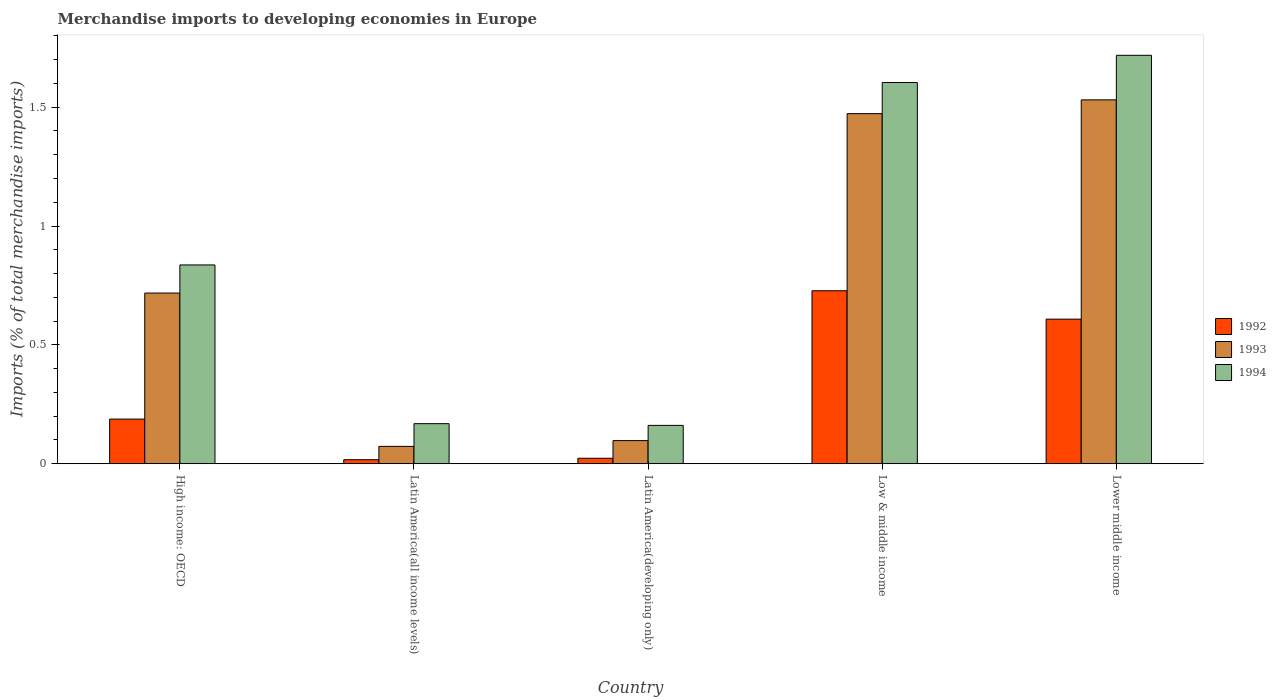How many different coloured bars are there?
Make the answer very short. 3. Are the number of bars per tick equal to the number of legend labels?
Give a very brief answer. Yes. How many bars are there on the 2nd tick from the left?
Offer a very short reply. 3. How many bars are there on the 3rd tick from the right?
Provide a succinct answer. 3. What is the label of the 2nd group of bars from the left?
Ensure brevity in your answer.  Latin America(all income levels). What is the percentage total merchandise imports in 1994 in Latin America(all income levels)?
Provide a short and direct response. 0.17. Across all countries, what is the maximum percentage total merchandise imports in 1993?
Make the answer very short. 1.53. Across all countries, what is the minimum percentage total merchandise imports in 1994?
Make the answer very short. 0.16. In which country was the percentage total merchandise imports in 1993 maximum?
Your answer should be very brief. Lower middle income. In which country was the percentage total merchandise imports in 1994 minimum?
Provide a succinct answer. Latin America(developing only). What is the total percentage total merchandise imports in 1994 in the graph?
Provide a short and direct response. 4.49. What is the difference between the percentage total merchandise imports in 1994 in Latin America(developing only) and that in Lower middle income?
Your answer should be very brief. -1.56. What is the difference between the percentage total merchandise imports in 1993 in Low & middle income and the percentage total merchandise imports in 1994 in High income: OECD?
Provide a succinct answer. 0.64. What is the average percentage total merchandise imports in 1992 per country?
Make the answer very short. 0.31. What is the difference between the percentage total merchandise imports of/in 1994 and percentage total merchandise imports of/in 1992 in Low & middle income?
Provide a short and direct response. 0.88. In how many countries, is the percentage total merchandise imports in 1994 greater than 0.9 %?
Provide a short and direct response. 2. What is the ratio of the percentage total merchandise imports in 1994 in High income: OECD to that in Low & middle income?
Offer a terse response. 0.52. Is the percentage total merchandise imports in 1994 in Latin America(all income levels) less than that in Low & middle income?
Make the answer very short. Yes. Is the difference between the percentage total merchandise imports in 1994 in Latin America(all income levels) and Latin America(developing only) greater than the difference between the percentage total merchandise imports in 1992 in Latin America(all income levels) and Latin America(developing only)?
Your answer should be very brief. Yes. What is the difference between the highest and the second highest percentage total merchandise imports in 1994?
Ensure brevity in your answer.  -0.88. What is the difference between the highest and the lowest percentage total merchandise imports in 1992?
Make the answer very short. 0.71. Is the sum of the percentage total merchandise imports in 1993 in Latin America(developing only) and Lower middle income greater than the maximum percentage total merchandise imports in 1992 across all countries?
Make the answer very short. Yes. Is it the case that in every country, the sum of the percentage total merchandise imports in 1994 and percentage total merchandise imports in 1993 is greater than the percentage total merchandise imports in 1992?
Provide a short and direct response. Yes. How many bars are there?
Give a very brief answer. 15. Are all the bars in the graph horizontal?
Keep it short and to the point. No. How many countries are there in the graph?
Offer a terse response. 5. Does the graph contain any zero values?
Provide a short and direct response. No. What is the title of the graph?
Provide a short and direct response. Merchandise imports to developing economies in Europe. Does "2014" appear as one of the legend labels in the graph?
Ensure brevity in your answer.  No. What is the label or title of the Y-axis?
Your answer should be compact. Imports (% of total merchandise imports). What is the Imports (% of total merchandise imports) in 1992 in High income: OECD?
Give a very brief answer. 0.19. What is the Imports (% of total merchandise imports) of 1993 in High income: OECD?
Offer a terse response. 0.72. What is the Imports (% of total merchandise imports) in 1994 in High income: OECD?
Your answer should be very brief. 0.84. What is the Imports (% of total merchandise imports) in 1992 in Latin America(all income levels)?
Make the answer very short. 0.02. What is the Imports (% of total merchandise imports) of 1993 in Latin America(all income levels)?
Offer a very short reply. 0.07. What is the Imports (% of total merchandise imports) in 1994 in Latin America(all income levels)?
Provide a short and direct response. 0.17. What is the Imports (% of total merchandise imports) of 1992 in Latin America(developing only)?
Give a very brief answer. 0.02. What is the Imports (% of total merchandise imports) of 1993 in Latin America(developing only)?
Provide a short and direct response. 0.1. What is the Imports (% of total merchandise imports) in 1994 in Latin America(developing only)?
Provide a short and direct response. 0.16. What is the Imports (% of total merchandise imports) in 1992 in Low & middle income?
Give a very brief answer. 0.73. What is the Imports (% of total merchandise imports) of 1993 in Low & middle income?
Provide a succinct answer. 1.47. What is the Imports (% of total merchandise imports) of 1994 in Low & middle income?
Provide a short and direct response. 1.6. What is the Imports (% of total merchandise imports) of 1992 in Lower middle income?
Provide a short and direct response. 0.61. What is the Imports (% of total merchandise imports) of 1993 in Lower middle income?
Offer a very short reply. 1.53. What is the Imports (% of total merchandise imports) in 1994 in Lower middle income?
Provide a short and direct response. 1.72. Across all countries, what is the maximum Imports (% of total merchandise imports) in 1992?
Offer a terse response. 0.73. Across all countries, what is the maximum Imports (% of total merchandise imports) in 1993?
Ensure brevity in your answer.  1.53. Across all countries, what is the maximum Imports (% of total merchandise imports) of 1994?
Your answer should be very brief. 1.72. Across all countries, what is the minimum Imports (% of total merchandise imports) of 1992?
Provide a short and direct response. 0.02. Across all countries, what is the minimum Imports (% of total merchandise imports) in 1993?
Give a very brief answer. 0.07. Across all countries, what is the minimum Imports (% of total merchandise imports) of 1994?
Your answer should be compact. 0.16. What is the total Imports (% of total merchandise imports) of 1992 in the graph?
Keep it short and to the point. 1.56. What is the total Imports (% of total merchandise imports) of 1993 in the graph?
Offer a very short reply. 3.89. What is the total Imports (% of total merchandise imports) of 1994 in the graph?
Keep it short and to the point. 4.49. What is the difference between the Imports (% of total merchandise imports) in 1992 in High income: OECD and that in Latin America(all income levels)?
Keep it short and to the point. 0.17. What is the difference between the Imports (% of total merchandise imports) of 1993 in High income: OECD and that in Latin America(all income levels)?
Your response must be concise. 0.65. What is the difference between the Imports (% of total merchandise imports) of 1994 in High income: OECD and that in Latin America(all income levels)?
Ensure brevity in your answer.  0.67. What is the difference between the Imports (% of total merchandise imports) in 1992 in High income: OECD and that in Latin America(developing only)?
Offer a very short reply. 0.16. What is the difference between the Imports (% of total merchandise imports) of 1993 in High income: OECD and that in Latin America(developing only)?
Your response must be concise. 0.62. What is the difference between the Imports (% of total merchandise imports) of 1994 in High income: OECD and that in Latin America(developing only)?
Provide a succinct answer. 0.67. What is the difference between the Imports (% of total merchandise imports) of 1992 in High income: OECD and that in Low & middle income?
Offer a very short reply. -0.54. What is the difference between the Imports (% of total merchandise imports) in 1993 in High income: OECD and that in Low & middle income?
Your response must be concise. -0.75. What is the difference between the Imports (% of total merchandise imports) of 1994 in High income: OECD and that in Low & middle income?
Provide a succinct answer. -0.77. What is the difference between the Imports (% of total merchandise imports) of 1992 in High income: OECD and that in Lower middle income?
Ensure brevity in your answer.  -0.42. What is the difference between the Imports (% of total merchandise imports) of 1993 in High income: OECD and that in Lower middle income?
Give a very brief answer. -0.81. What is the difference between the Imports (% of total merchandise imports) in 1994 in High income: OECD and that in Lower middle income?
Your answer should be very brief. -0.88. What is the difference between the Imports (% of total merchandise imports) of 1992 in Latin America(all income levels) and that in Latin America(developing only)?
Offer a terse response. -0.01. What is the difference between the Imports (% of total merchandise imports) of 1993 in Latin America(all income levels) and that in Latin America(developing only)?
Offer a very short reply. -0.02. What is the difference between the Imports (% of total merchandise imports) of 1994 in Latin America(all income levels) and that in Latin America(developing only)?
Make the answer very short. 0.01. What is the difference between the Imports (% of total merchandise imports) in 1992 in Latin America(all income levels) and that in Low & middle income?
Your answer should be compact. -0.71. What is the difference between the Imports (% of total merchandise imports) in 1993 in Latin America(all income levels) and that in Low & middle income?
Keep it short and to the point. -1.4. What is the difference between the Imports (% of total merchandise imports) in 1994 in Latin America(all income levels) and that in Low & middle income?
Ensure brevity in your answer.  -1.44. What is the difference between the Imports (% of total merchandise imports) in 1992 in Latin America(all income levels) and that in Lower middle income?
Your answer should be very brief. -0.59. What is the difference between the Imports (% of total merchandise imports) of 1993 in Latin America(all income levels) and that in Lower middle income?
Your answer should be very brief. -1.46. What is the difference between the Imports (% of total merchandise imports) in 1994 in Latin America(all income levels) and that in Lower middle income?
Your answer should be very brief. -1.55. What is the difference between the Imports (% of total merchandise imports) of 1992 in Latin America(developing only) and that in Low & middle income?
Offer a terse response. -0.7. What is the difference between the Imports (% of total merchandise imports) of 1993 in Latin America(developing only) and that in Low & middle income?
Provide a succinct answer. -1.38. What is the difference between the Imports (% of total merchandise imports) in 1994 in Latin America(developing only) and that in Low & middle income?
Keep it short and to the point. -1.44. What is the difference between the Imports (% of total merchandise imports) in 1992 in Latin America(developing only) and that in Lower middle income?
Offer a terse response. -0.59. What is the difference between the Imports (% of total merchandise imports) of 1993 in Latin America(developing only) and that in Lower middle income?
Offer a very short reply. -1.43. What is the difference between the Imports (% of total merchandise imports) in 1994 in Latin America(developing only) and that in Lower middle income?
Ensure brevity in your answer.  -1.56. What is the difference between the Imports (% of total merchandise imports) of 1992 in Low & middle income and that in Lower middle income?
Offer a very short reply. 0.12. What is the difference between the Imports (% of total merchandise imports) in 1993 in Low & middle income and that in Lower middle income?
Provide a succinct answer. -0.06. What is the difference between the Imports (% of total merchandise imports) of 1994 in Low & middle income and that in Lower middle income?
Make the answer very short. -0.11. What is the difference between the Imports (% of total merchandise imports) of 1992 in High income: OECD and the Imports (% of total merchandise imports) of 1993 in Latin America(all income levels)?
Provide a short and direct response. 0.11. What is the difference between the Imports (% of total merchandise imports) in 1992 in High income: OECD and the Imports (% of total merchandise imports) in 1994 in Latin America(all income levels)?
Offer a terse response. 0.02. What is the difference between the Imports (% of total merchandise imports) of 1993 in High income: OECD and the Imports (% of total merchandise imports) of 1994 in Latin America(all income levels)?
Give a very brief answer. 0.55. What is the difference between the Imports (% of total merchandise imports) of 1992 in High income: OECD and the Imports (% of total merchandise imports) of 1993 in Latin America(developing only)?
Your response must be concise. 0.09. What is the difference between the Imports (% of total merchandise imports) of 1992 in High income: OECD and the Imports (% of total merchandise imports) of 1994 in Latin America(developing only)?
Make the answer very short. 0.03. What is the difference between the Imports (% of total merchandise imports) of 1993 in High income: OECD and the Imports (% of total merchandise imports) of 1994 in Latin America(developing only)?
Your answer should be very brief. 0.56. What is the difference between the Imports (% of total merchandise imports) in 1992 in High income: OECD and the Imports (% of total merchandise imports) in 1993 in Low & middle income?
Your response must be concise. -1.28. What is the difference between the Imports (% of total merchandise imports) of 1992 in High income: OECD and the Imports (% of total merchandise imports) of 1994 in Low & middle income?
Give a very brief answer. -1.42. What is the difference between the Imports (% of total merchandise imports) of 1993 in High income: OECD and the Imports (% of total merchandise imports) of 1994 in Low & middle income?
Make the answer very short. -0.89. What is the difference between the Imports (% of total merchandise imports) of 1992 in High income: OECD and the Imports (% of total merchandise imports) of 1993 in Lower middle income?
Provide a succinct answer. -1.34. What is the difference between the Imports (% of total merchandise imports) of 1992 in High income: OECD and the Imports (% of total merchandise imports) of 1994 in Lower middle income?
Offer a very short reply. -1.53. What is the difference between the Imports (% of total merchandise imports) in 1993 in High income: OECD and the Imports (% of total merchandise imports) in 1994 in Lower middle income?
Your response must be concise. -1. What is the difference between the Imports (% of total merchandise imports) in 1992 in Latin America(all income levels) and the Imports (% of total merchandise imports) in 1993 in Latin America(developing only)?
Ensure brevity in your answer.  -0.08. What is the difference between the Imports (% of total merchandise imports) in 1992 in Latin America(all income levels) and the Imports (% of total merchandise imports) in 1994 in Latin America(developing only)?
Provide a succinct answer. -0.14. What is the difference between the Imports (% of total merchandise imports) of 1993 in Latin America(all income levels) and the Imports (% of total merchandise imports) of 1994 in Latin America(developing only)?
Offer a terse response. -0.09. What is the difference between the Imports (% of total merchandise imports) of 1992 in Latin America(all income levels) and the Imports (% of total merchandise imports) of 1993 in Low & middle income?
Provide a succinct answer. -1.46. What is the difference between the Imports (% of total merchandise imports) of 1992 in Latin America(all income levels) and the Imports (% of total merchandise imports) of 1994 in Low & middle income?
Offer a very short reply. -1.59. What is the difference between the Imports (% of total merchandise imports) in 1993 in Latin America(all income levels) and the Imports (% of total merchandise imports) in 1994 in Low & middle income?
Keep it short and to the point. -1.53. What is the difference between the Imports (% of total merchandise imports) of 1992 in Latin America(all income levels) and the Imports (% of total merchandise imports) of 1993 in Lower middle income?
Provide a short and direct response. -1.51. What is the difference between the Imports (% of total merchandise imports) of 1992 in Latin America(all income levels) and the Imports (% of total merchandise imports) of 1994 in Lower middle income?
Your response must be concise. -1.7. What is the difference between the Imports (% of total merchandise imports) in 1993 in Latin America(all income levels) and the Imports (% of total merchandise imports) in 1994 in Lower middle income?
Your answer should be compact. -1.65. What is the difference between the Imports (% of total merchandise imports) in 1992 in Latin America(developing only) and the Imports (% of total merchandise imports) in 1993 in Low & middle income?
Provide a short and direct response. -1.45. What is the difference between the Imports (% of total merchandise imports) in 1992 in Latin America(developing only) and the Imports (% of total merchandise imports) in 1994 in Low & middle income?
Provide a short and direct response. -1.58. What is the difference between the Imports (% of total merchandise imports) in 1993 in Latin America(developing only) and the Imports (% of total merchandise imports) in 1994 in Low & middle income?
Make the answer very short. -1.51. What is the difference between the Imports (% of total merchandise imports) of 1992 in Latin America(developing only) and the Imports (% of total merchandise imports) of 1993 in Lower middle income?
Ensure brevity in your answer.  -1.51. What is the difference between the Imports (% of total merchandise imports) of 1992 in Latin America(developing only) and the Imports (% of total merchandise imports) of 1994 in Lower middle income?
Your answer should be compact. -1.7. What is the difference between the Imports (% of total merchandise imports) in 1993 in Latin America(developing only) and the Imports (% of total merchandise imports) in 1994 in Lower middle income?
Offer a terse response. -1.62. What is the difference between the Imports (% of total merchandise imports) in 1992 in Low & middle income and the Imports (% of total merchandise imports) in 1993 in Lower middle income?
Give a very brief answer. -0.8. What is the difference between the Imports (% of total merchandise imports) in 1992 in Low & middle income and the Imports (% of total merchandise imports) in 1994 in Lower middle income?
Provide a short and direct response. -0.99. What is the difference between the Imports (% of total merchandise imports) of 1993 in Low & middle income and the Imports (% of total merchandise imports) of 1994 in Lower middle income?
Ensure brevity in your answer.  -0.25. What is the average Imports (% of total merchandise imports) in 1992 per country?
Your response must be concise. 0.31. What is the average Imports (% of total merchandise imports) of 1993 per country?
Make the answer very short. 0.78. What is the average Imports (% of total merchandise imports) of 1994 per country?
Ensure brevity in your answer.  0.9. What is the difference between the Imports (% of total merchandise imports) of 1992 and Imports (% of total merchandise imports) of 1993 in High income: OECD?
Your answer should be compact. -0.53. What is the difference between the Imports (% of total merchandise imports) of 1992 and Imports (% of total merchandise imports) of 1994 in High income: OECD?
Ensure brevity in your answer.  -0.65. What is the difference between the Imports (% of total merchandise imports) in 1993 and Imports (% of total merchandise imports) in 1994 in High income: OECD?
Offer a very short reply. -0.12. What is the difference between the Imports (% of total merchandise imports) in 1992 and Imports (% of total merchandise imports) in 1993 in Latin America(all income levels)?
Give a very brief answer. -0.06. What is the difference between the Imports (% of total merchandise imports) of 1992 and Imports (% of total merchandise imports) of 1994 in Latin America(all income levels)?
Provide a succinct answer. -0.15. What is the difference between the Imports (% of total merchandise imports) of 1993 and Imports (% of total merchandise imports) of 1994 in Latin America(all income levels)?
Make the answer very short. -0.1. What is the difference between the Imports (% of total merchandise imports) of 1992 and Imports (% of total merchandise imports) of 1993 in Latin America(developing only)?
Your answer should be very brief. -0.07. What is the difference between the Imports (% of total merchandise imports) in 1992 and Imports (% of total merchandise imports) in 1994 in Latin America(developing only)?
Ensure brevity in your answer.  -0.14. What is the difference between the Imports (% of total merchandise imports) in 1993 and Imports (% of total merchandise imports) in 1994 in Latin America(developing only)?
Ensure brevity in your answer.  -0.06. What is the difference between the Imports (% of total merchandise imports) of 1992 and Imports (% of total merchandise imports) of 1993 in Low & middle income?
Offer a terse response. -0.74. What is the difference between the Imports (% of total merchandise imports) of 1992 and Imports (% of total merchandise imports) of 1994 in Low & middle income?
Your answer should be very brief. -0.88. What is the difference between the Imports (% of total merchandise imports) in 1993 and Imports (% of total merchandise imports) in 1994 in Low & middle income?
Give a very brief answer. -0.13. What is the difference between the Imports (% of total merchandise imports) of 1992 and Imports (% of total merchandise imports) of 1993 in Lower middle income?
Your response must be concise. -0.92. What is the difference between the Imports (% of total merchandise imports) of 1992 and Imports (% of total merchandise imports) of 1994 in Lower middle income?
Ensure brevity in your answer.  -1.11. What is the difference between the Imports (% of total merchandise imports) of 1993 and Imports (% of total merchandise imports) of 1994 in Lower middle income?
Keep it short and to the point. -0.19. What is the ratio of the Imports (% of total merchandise imports) in 1992 in High income: OECD to that in Latin America(all income levels)?
Give a very brief answer. 11.1. What is the ratio of the Imports (% of total merchandise imports) of 1993 in High income: OECD to that in Latin America(all income levels)?
Your answer should be very brief. 9.84. What is the ratio of the Imports (% of total merchandise imports) in 1994 in High income: OECD to that in Latin America(all income levels)?
Offer a very short reply. 4.96. What is the ratio of the Imports (% of total merchandise imports) of 1992 in High income: OECD to that in Latin America(developing only)?
Your answer should be very brief. 8.15. What is the ratio of the Imports (% of total merchandise imports) in 1993 in High income: OECD to that in Latin America(developing only)?
Your answer should be compact. 7.38. What is the ratio of the Imports (% of total merchandise imports) in 1994 in High income: OECD to that in Latin America(developing only)?
Your answer should be very brief. 5.18. What is the ratio of the Imports (% of total merchandise imports) in 1992 in High income: OECD to that in Low & middle income?
Make the answer very short. 0.26. What is the ratio of the Imports (% of total merchandise imports) of 1993 in High income: OECD to that in Low & middle income?
Your response must be concise. 0.49. What is the ratio of the Imports (% of total merchandise imports) in 1994 in High income: OECD to that in Low & middle income?
Provide a short and direct response. 0.52. What is the ratio of the Imports (% of total merchandise imports) of 1992 in High income: OECD to that in Lower middle income?
Offer a very short reply. 0.31. What is the ratio of the Imports (% of total merchandise imports) of 1993 in High income: OECD to that in Lower middle income?
Offer a terse response. 0.47. What is the ratio of the Imports (% of total merchandise imports) in 1994 in High income: OECD to that in Lower middle income?
Provide a short and direct response. 0.49. What is the ratio of the Imports (% of total merchandise imports) in 1992 in Latin America(all income levels) to that in Latin America(developing only)?
Give a very brief answer. 0.73. What is the ratio of the Imports (% of total merchandise imports) in 1993 in Latin America(all income levels) to that in Latin America(developing only)?
Give a very brief answer. 0.75. What is the ratio of the Imports (% of total merchandise imports) of 1994 in Latin America(all income levels) to that in Latin America(developing only)?
Your answer should be compact. 1.04. What is the ratio of the Imports (% of total merchandise imports) of 1992 in Latin America(all income levels) to that in Low & middle income?
Your answer should be very brief. 0.02. What is the ratio of the Imports (% of total merchandise imports) of 1993 in Latin America(all income levels) to that in Low & middle income?
Offer a very short reply. 0.05. What is the ratio of the Imports (% of total merchandise imports) of 1994 in Latin America(all income levels) to that in Low & middle income?
Provide a succinct answer. 0.11. What is the ratio of the Imports (% of total merchandise imports) of 1992 in Latin America(all income levels) to that in Lower middle income?
Your answer should be very brief. 0.03. What is the ratio of the Imports (% of total merchandise imports) of 1993 in Latin America(all income levels) to that in Lower middle income?
Keep it short and to the point. 0.05. What is the ratio of the Imports (% of total merchandise imports) of 1994 in Latin America(all income levels) to that in Lower middle income?
Offer a terse response. 0.1. What is the ratio of the Imports (% of total merchandise imports) in 1992 in Latin America(developing only) to that in Low & middle income?
Provide a short and direct response. 0.03. What is the ratio of the Imports (% of total merchandise imports) in 1993 in Latin America(developing only) to that in Low & middle income?
Offer a very short reply. 0.07. What is the ratio of the Imports (% of total merchandise imports) of 1994 in Latin America(developing only) to that in Low & middle income?
Provide a succinct answer. 0.1. What is the ratio of the Imports (% of total merchandise imports) of 1992 in Latin America(developing only) to that in Lower middle income?
Give a very brief answer. 0.04. What is the ratio of the Imports (% of total merchandise imports) of 1993 in Latin America(developing only) to that in Lower middle income?
Offer a very short reply. 0.06. What is the ratio of the Imports (% of total merchandise imports) of 1994 in Latin America(developing only) to that in Lower middle income?
Your answer should be compact. 0.09. What is the ratio of the Imports (% of total merchandise imports) in 1992 in Low & middle income to that in Lower middle income?
Ensure brevity in your answer.  1.2. What is the ratio of the Imports (% of total merchandise imports) in 1993 in Low & middle income to that in Lower middle income?
Your response must be concise. 0.96. What is the ratio of the Imports (% of total merchandise imports) in 1994 in Low & middle income to that in Lower middle income?
Give a very brief answer. 0.93. What is the difference between the highest and the second highest Imports (% of total merchandise imports) of 1992?
Offer a very short reply. 0.12. What is the difference between the highest and the second highest Imports (% of total merchandise imports) of 1993?
Keep it short and to the point. 0.06. What is the difference between the highest and the second highest Imports (% of total merchandise imports) of 1994?
Ensure brevity in your answer.  0.11. What is the difference between the highest and the lowest Imports (% of total merchandise imports) in 1992?
Offer a very short reply. 0.71. What is the difference between the highest and the lowest Imports (% of total merchandise imports) of 1993?
Provide a short and direct response. 1.46. What is the difference between the highest and the lowest Imports (% of total merchandise imports) in 1994?
Provide a short and direct response. 1.56. 